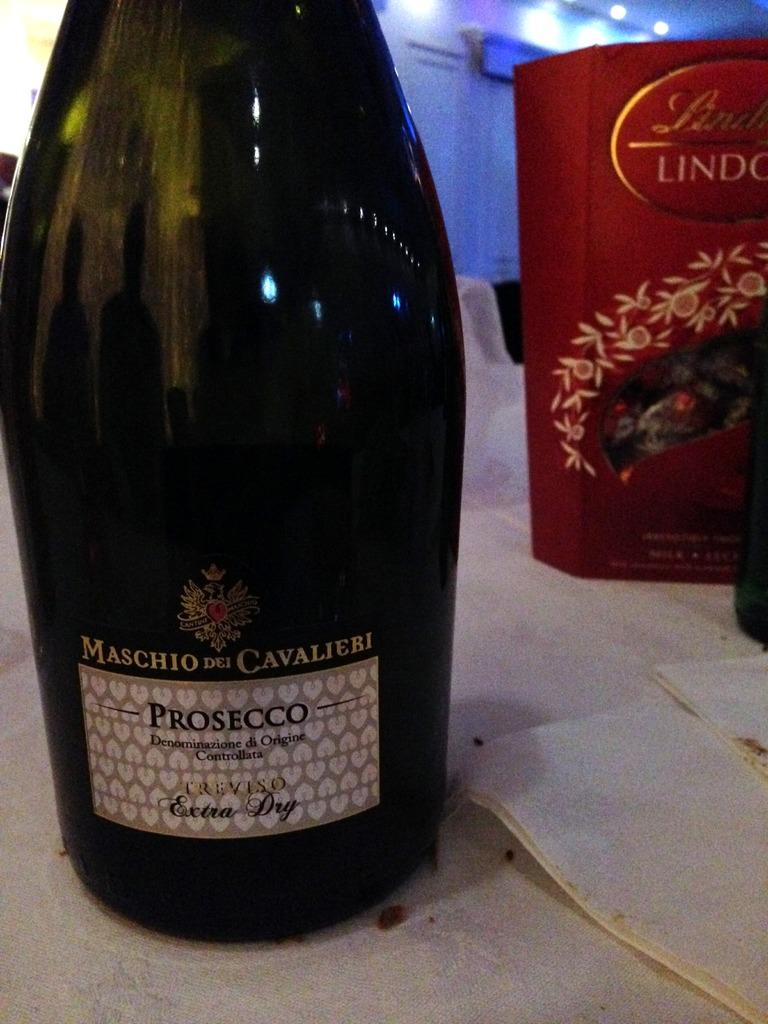<image>
Share a concise interpretation of the image provided. A bottle of MASCHIO DEL CAVALIERI PROSECCO Extra Dry and Lindt chocolates are partially shown. 